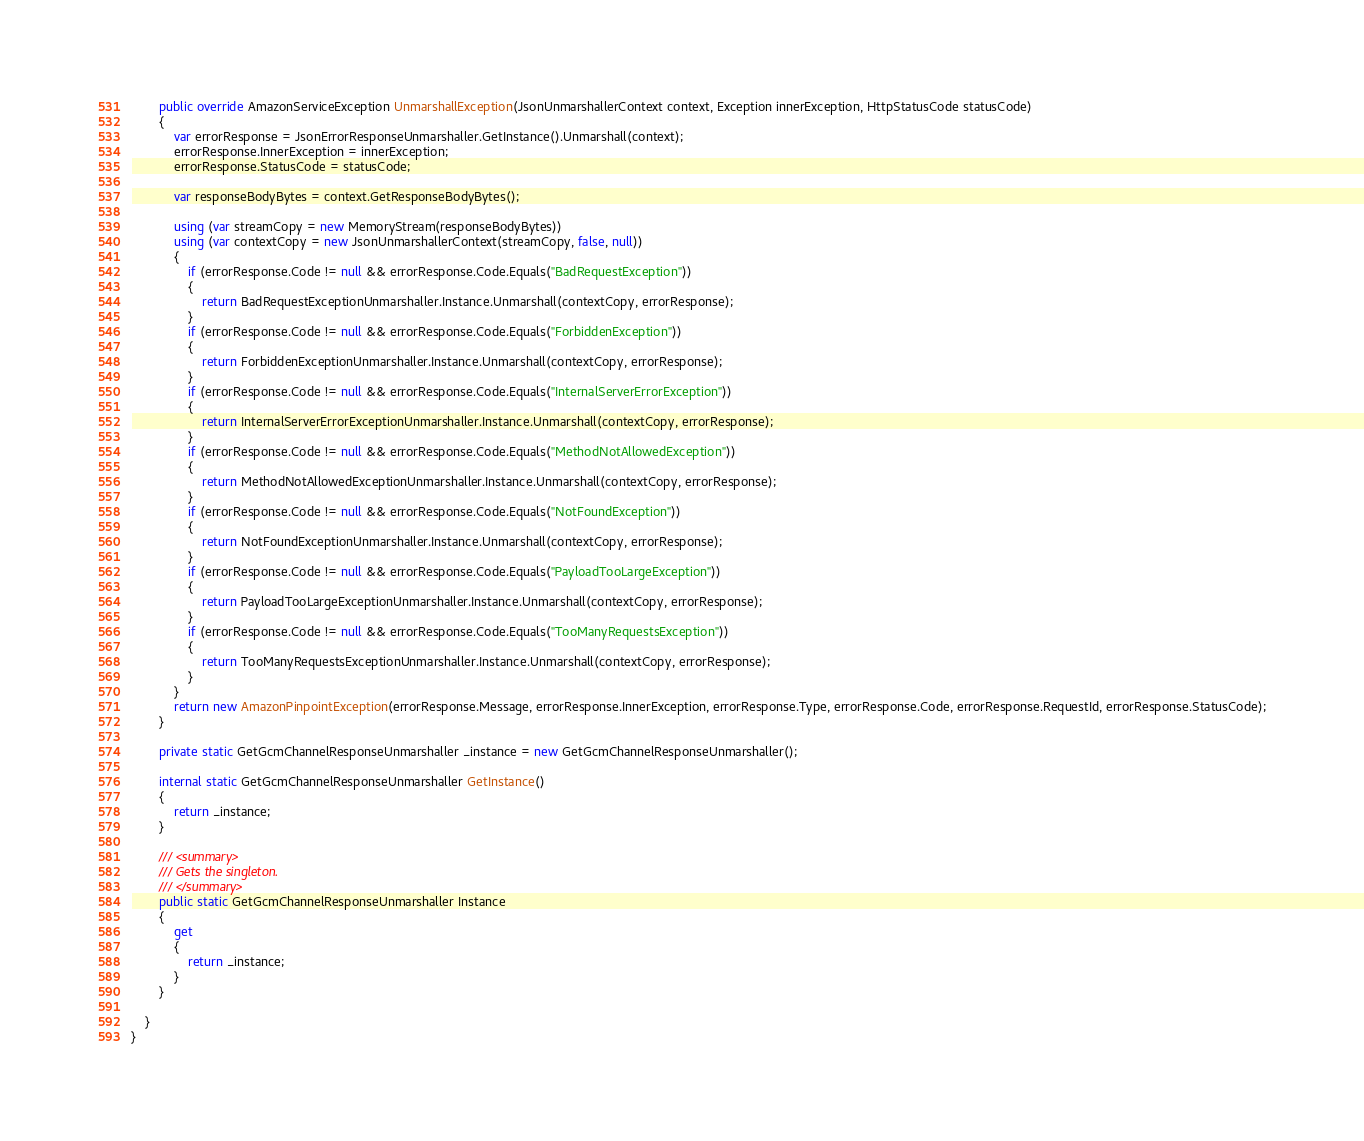Convert code to text. <code><loc_0><loc_0><loc_500><loc_500><_C#_>        public override AmazonServiceException UnmarshallException(JsonUnmarshallerContext context, Exception innerException, HttpStatusCode statusCode)
        {
            var errorResponse = JsonErrorResponseUnmarshaller.GetInstance().Unmarshall(context);
            errorResponse.InnerException = innerException;
            errorResponse.StatusCode = statusCode;

            var responseBodyBytes = context.GetResponseBodyBytes();

            using (var streamCopy = new MemoryStream(responseBodyBytes))
            using (var contextCopy = new JsonUnmarshallerContext(streamCopy, false, null))
            {
                if (errorResponse.Code != null && errorResponse.Code.Equals("BadRequestException"))
                {
                    return BadRequestExceptionUnmarshaller.Instance.Unmarshall(contextCopy, errorResponse);
                }
                if (errorResponse.Code != null && errorResponse.Code.Equals("ForbiddenException"))
                {
                    return ForbiddenExceptionUnmarshaller.Instance.Unmarshall(contextCopy, errorResponse);
                }
                if (errorResponse.Code != null && errorResponse.Code.Equals("InternalServerErrorException"))
                {
                    return InternalServerErrorExceptionUnmarshaller.Instance.Unmarshall(contextCopy, errorResponse);
                }
                if (errorResponse.Code != null && errorResponse.Code.Equals("MethodNotAllowedException"))
                {
                    return MethodNotAllowedExceptionUnmarshaller.Instance.Unmarshall(contextCopy, errorResponse);
                }
                if (errorResponse.Code != null && errorResponse.Code.Equals("NotFoundException"))
                {
                    return NotFoundExceptionUnmarshaller.Instance.Unmarshall(contextCopy, errorResponse);
                }
                if (errorResponse.Code != null && errorResponse.Code.Equals("PayloadTooLargeException"))
                {
                    return PayloadTooLargeExceptionUnmarshaller.Instance.Unmarshall(contextCopy, errorResponse);
                }
                if (errorResponse.Code != null && errorResponse.Code.Equals("TooManyRequestsException"))
                {
                    return TooManyRequestsExceptionUnmarshaller.Instance.Unmarshall(contextCopy, errorResponse);
                }
            }
            return new AmazonPinpointException(errorResponse.Message, errorResponse.InnerException, errorResponse.Type, errorResponse.Code, errorResponse.RequestId, errorResponse.StatusCode);
        }

        private static GetGcmChannelResponseUnmarshaller _instance = new GetGcmChannelResponseUnmarshaller();        

        internal static GetGcmChannelResponseUnmarshaller GetInstance()
        {
            return _instance;
        }

        /// <summary>
        /// Gets the singleton.
        /// </summary>  
        public static GetGcmChannelResponseUnmarshaller Instance
        {
            get
            {
                return _instance;
            }
        }

    }
}</code> 